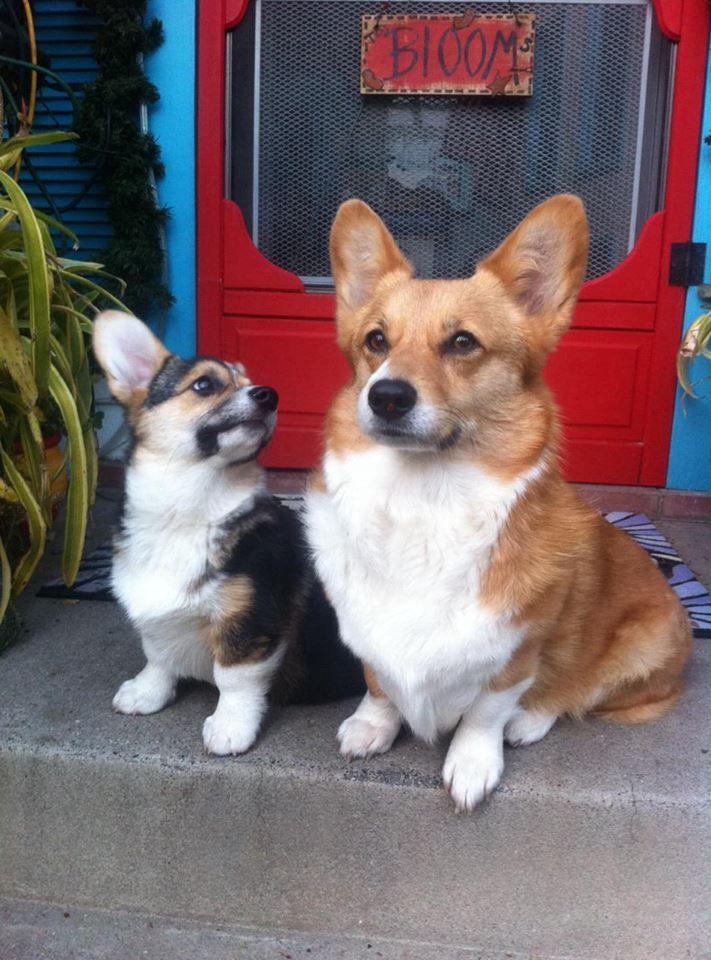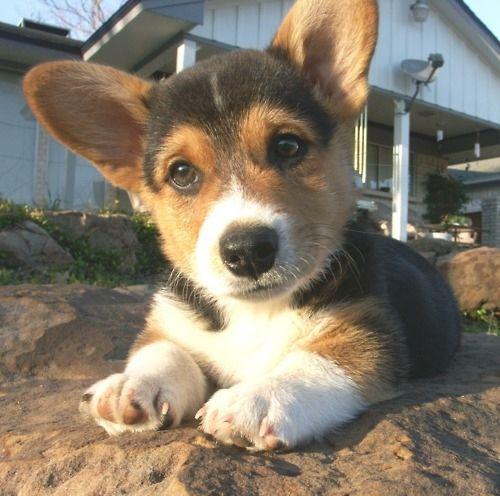The first image is the image on the left, the second image is the image on the right. For the images displayed, is the sentence "Less than four corgis are in the pair." factually correct? Answer yes or no. Yes. The first image is the image on the left, the second image is the image on the right. Given the left and right images, does the statement "The right image contains at least two dogs." hold true? Answer yes or no. No. 